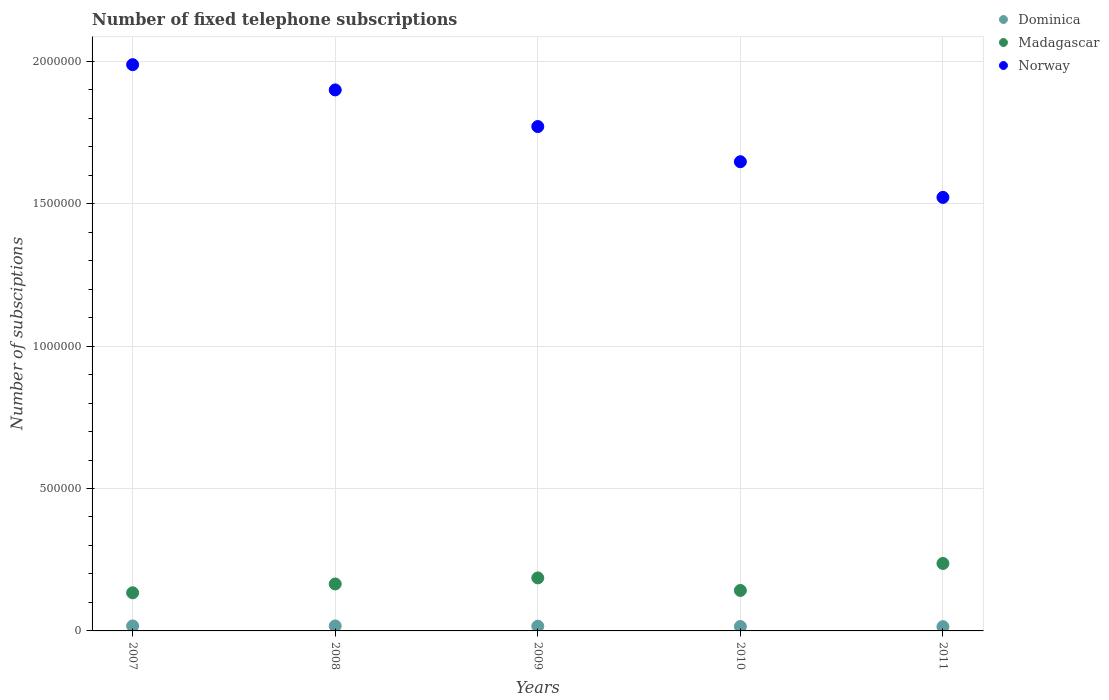Is the number of dotlines equal to the number of legend labels?
Your response must be concise. Yes. What is the number of fixed telephone subscriptions in Norway in 2010?
Ensure brevity in your answer.  1.65e+06. Across all years, what is the maximum number of fixed telephone subscriptions in Madagascar?
Offer a terse response. 2.37e+05. Across all years, what is the minimum number of fixed telephone subscriptions in Dominica?
Keep it short and to the point. 1.50e+04. In which year was the number of fixed telephone subscriptions in Madagascar minimum?
Offer a very short reply. 2007. What is the total number of fixed telephone subscriptions in Norway in the graph?
Make the answer very short. 8.83e+06. What is the difference between the number of fixed telephone subscriptions in Norway in 2008 and that in 2009?
Make the answer very short. 1.29e+05. What is the difference between the number of fixed telephone subscriptions in Norway in 2011 and the number of fixed telephone subscriptions in Dominica in 2009?
Your answer should be compact. 1.51e+06. What is the average number of fixed telephone subscriptions in Norway per year?
Offer a terse response. 1.77e+06. In the year 2011, what is the difference between the number of fixed telephone subscriptions in Norway and number of fixed telephone subscriptions in Dominica?
Your answer should be compact. 1.51e+06. In how many years, is the number of fixed telephone subscriptions in Dominica greater than 1400000?
Ensure brevity in your answer.  0. What is the ratio of the number of fixed telephone subscriptions in Dominica in 2007 to that in 2011?
Your response must be concise. 1.16. What is the difference between the highest and the second highest number of fixed telephone subscriptions in Norway?
Keep it short and to the point. 8.86e+04. What is the difference between the highest and the lowest number of fixed telephone subscriptions in Norway?
Keep it short and to the point. 4.66e+05. Is the sum of the number of fixed telephone subscriptions in Madagascar in 2010 and 2011 greater than the maximum number of fixed telephone subscriptions in Dominica across all years?
Make the answer very short. Yes. Is it the case that in every year, the sum of the number of fixed telephone subscriptions in Norway and number of fixed telephone subscriptions in Dominica  is greater than the number of fixed telephone subscriptions in Madagascar?
Offer a terse response. Yes. Is the number of fixed telephone subscriptions in Madagascar strictly greater than the number of fixed telephone subscriptions in Dominica over the years?
Offer a terse response. Yes. How many years are there in the graph?
Offer a very short reply. 5. Are the values on the major ticks of Y-axis written in scientific E-notation?
Provide a short and direct response. No. Does the graph contain grids?
Provide a succinct answer. Yes. Where does the legend appear in the graph?
Keep it short and to the point. Top right. How are the legend labels stacked?
Your response must be concise. Vertical. What is the title of the graph?
Offer a terse response. Number of fixed telephone subscriptions. What is the label or title of the Y-axis?
Provide a succinct answer. Number of subsciptions. What is the Number of subsciptions of Dominica in 2007?
Keep it short and to the point. 1.74e+04. What is the Number of subsciptions of Madagascar in 2007?
Make the answer very short. 1.34e+05. What is the Number of subsciptions of Norway in 2007?
Your answer should be compact. 1.99e+06. What is the Number of subsciptions in Dominica in 2008?
Ensure brevity in your answer.  1.75e+04. What is the Number of subsciptions of Madagascar in 2008?
Provide a short and direct response. 1.65e+05. What is the Number of subsciptions in Norway in 2008?
Provide a short and direct response. 1.90e+06. What is the Number of subsciptions in Dominica in 2009?
Your answer should be compact. 1.65e+04. What is the Number of subsciptions in Madagascar in 2009?
Your answer should be very brief. 1.86e+05. What is the Number of subsciptions of Norway in 2009?
Ensure brevity in your answer.  1.77e+06. What is the Number of subsciptions in Dominica in 2010?
Your response must be concise. 1.55e+04. What is the Number of subsciptions in Madagascar in 2010?
Offer a terse response. 1.42e+05. What is the Number of subsciptions in Norway in 2010?
Give a very brief answer. 1.65e+06. What is the Number of subsciptions of Dominica in 2011?
Your answer should be compact. 1.50e+04. What is the Number of subsciptions of Madagascar in 2011?
Keep it short and to the point. 2.37e+05. What is the Number of subsciptions in Norway in 2011?
Your response must be concise. 1.52e+06. Across all years, what is the maximum Number of subsciptions of Dominica?
Your answer should be very brief. 1.75e+04. Across all years, what is the maximum Number of subsciptions in Madagascar?
Offer a terse response. 2.37e+05. Across all years, what is the maximum Number of subsciptions in Norway?
Your answer should be very brief. 1.99e+06. Across all years, what is the minimum Number of subsciptions of Dominica?
Offer a terse response. 1.50e+04. Across all years, what is the minimum Number of subsciptions of Madagascar?
Your response must be concise. 1.34e+05. Across all years, what is the minimum Number of subsciptions of Norway?
Your answer should be very brief. 1.52e+06. What is the total Number of subsciptions of Dominica in the graph?
Make the answer very short. 8.19e+04. What is the total Number of subsciptions of Madagascar in the graph?
Provide a short and direct response. 8.64e+05. What is the total Number of subsciptions of Norway in the graph?
Offer a terse response. 8.83e+06. What is the difference between the Number of subsciptions in Dominica in 2007 and that in 2008?
Your answer should be compact. -50. What is the difference between the Number of subsciptions in Madagascar in 2007 and that in 2008?
Your answer should be very brief. -3.10e+04. What is the difference between the Number of subsciptions of Norway in 2007 and that in 2008?
Provide a short and direct response. 8.86e+04. What is the difference between the Number of subsciptions in Dominica in 2007 and that in 2009?
Make the answer very short. 950. What is the difference between the Number of subsciptions in Madagascar in 2007 and that in 2009?
Provide a short and direct response. -5.23e+04. What is the difference between the Number of subsciptions in Norway in 2007 and that in 2009?
Ensure brevity in your answer.  2.17e+05. What is the difference between the Number of subsciptions in Dominica in 2007 and that in 2010?
Offer a terse response. 1966. What is the difference between the Number of subsciptions in Madagascar in 2007 and that in 2010?
Give a very brief answer. -8171. What is the difference between the Number of subsciptions in Norway in 2007 and that in 2010?
Ensure brevity in your answer.  3.41e+05. What is the difference between the Number of subsciptions of Dominica in 2007 and that in 2011?
Your answer should be compact. 2458. What is the difference between the Number of subsciptions in Madagascar in 2007 and that in 2011?
Give a very brief answer. -1.03e+05. What is the difference between the Number of subsciptions of Norway in 2007 and that in 2011?
Your answer should be very brief. 4.66e+05. What is the difference between the Number of subsciptions in Madagascar in 2008 and that in 2009?
Keep it short and to the point. -2.13e+04. What is the difference between the Number of subsciptions in Norway in 2008 and that in 2009?
Offer a very short reply. 1.29e+05. What is the difference between the Number of subsciptions of Dominica in 2008 and that in 2010?
Your answer should be compact. 2016. What is the difference between the Number of subsciptions of Madagascar in 2008 and that in 2010?
Ensure brevity in your answer.  2.28e+04. What is the difference between the Number of subsciptions in Norway in 2008 and that in 2010?
Your response must be concise. 2.52e+05. What is the difference between the Number of subsciptions in Dominica in 2008 and that in 2011?
Provide a succinct answer. 2508. What is the difference between the Number of subsciptions in Madagascar in 2008 and that in 2011?
Keep it short and to the point. -7.20e+04. What is the difference between the Number of subsciptions of Norway in 2008 and that in 2011?
Provide a short and direct response. 3.77e+05. What is the difference between the Number of subsciptions in Dominica in 2009 and that in 2010?
Provide a short and direct response. 1016. What is the difference between the Number of subsciptions of Madagascar in 2009 and that in 2010?
Your answer should be very brief. 4.41e+04. What is the difference between the Number of subsciptions in Norway in 2009 and that in 2010?
Make the answer very short. 1.24e+05. What is the difference between the Number of subsciptions in Dominica in 2009 and that in 2011?
Give a very brief answer. 1508. What is the difference between the Number of subsciptions of Madagascar in 2009 and that in 2011?
Make the answer very short. -5.07e+04. What is the difference between the Number of subsciptions in Norway in 2009 and that in 2011?
Give a very brief answer. 2.49e+05. What is the difference between the Number of subsciptions of Dominica in 2010 and that in 2011?
Ensure brevity in your answer.  492. What is the difference between the Number of subsciptions in Madagascar in 2010 and that in 2011?
Your answer should be compact. -9.48e+04. What is the difference between the Number of subsciptions in Norway in 2010 and that in 2011?
Provide a short and direct response. 1.25e+05. What is the difference between the Number of subsciptions in Dominica in 2007 and the Number of subsciptions in Madagascar in 2008?
Make the answer very short. -1.47e+05. What is the difference between the Number of subsciptions in Dominica in 2007 and the Number of subsciptions in Norway in 2008?
Provide a short and direct response. -1.88e+06. What is the difference between the Number of subsciptions in Madagascar in 2007 and the Number of subsciptions in Norway in 2008?
Offer a terse response. -1.77e+06. What is the difference between the Number of subsciptions in Dominica in 2007 and the Number of subsciptions in Madagascar in 2009?
Your response must be concise. -1.69e+05. What is the difference between the Number of subsciptions in Dominica in 2007 and the Number of subsciptions in Norway in 2009?
Make the answer very short. -1.75e+06. What is the difference between the Number of subsciptions in Madagascar in 2007 and the Number of subsciptions in Norway in 2009?
Provide a succinct answer. -1.64e+06. What is the difference between the Number of subsciptions in Dominica in 2007 and the Number of subsciptions in Madagascar in 2010?
Keep it short and to the point. -1.25e+05. What is the difference between the Number of subsciptions of Dominica in 2007 and the Number of subsciptions of Norway in 2010?
Your response must be concise. -1.63e+06. What is the difference between the Number of subsciptions in Madagascar in 2007 and the Number of subsciptions in Norway in 2010?
Give a very brief answer. -1.51e+06. What is the difference between the Number of subsciptions of Dominica in 2007 and the Number of subsciptions of Madagascar in 2011?
Your answer should be very brief. -2.19e+05. What is the difference between the Number of subsciptions in Dominica in 2007 and the Number of subsciptions in Norway in 2011?
Offer a very short reply. -1.50e+06. What is the difference between the Number of subsciptions of Madagascar in 2007 and the Number of subsciptions of Norway in 2011?
Provide a short and direct response. -1.39e+06. What is the difference between the Number of subsciptions of Dominica in 2008 and the Number of subsciptions of Madagascar in 2009?
Offer a terse response. -1.69e+05. What is the difference between the Number of subsciptions of Dominica in 2008 and the Number of subsciptions of Norway in 2009?
Keep it short and to the point. -1.75e+06. What is the difference between the Number of subsciptions of Madagascar in 2008 and the Number of subsciptions of Norway in 2009?
Your answer should be very brief. -1.61e+06. What is the difference between the Number of subsciptions in Dominica in 2008 and the Number of subsciptions in Madagascar in 2010?
Provide a succinct answer. -1.25e+05. What is the difference between the Number of subsciptions of Dominica in 2008 and the Number of subsciptions of Norway in 2010?
Your answer should be compact. -1.63e+06. What is the difference between the Number of subsciptions in Madagascar in 2008 and the Number of subsciptions in Norway in 2010?
Provide a short and direct response. -1.48e+06. What is the difference between the Number of subsciptions of Dominica in 2008 and the Number of subsciptions of Madagascar in 2011?
Provide a succinct answer. -2.19e+05. What is the difference between the Number of subsciptions of Dominica in 2008 and the Number of subsciptions of Norway in 2011?
Make the answer very short. -1.50e+06. What is the difference between the Number of subsciptions of Madagascar in 2008 and the Number of subsciptions of Norway in 2011?
Provide a succinct answer. -1.36e+06. What is the difference between the Number of subsciptions of Dominica in 2009 and the Number of subsciptions of Madagascar in 2010?
Make the answer very short. -1.26e+05. What is the difference between the Number of subsciptions in Dominica in 2009 and the Number of subsciptions in Norway in 2010?
Your answer should be compact. -1.63e+06. What is the difference between the Number of subsciptions of Madagascar in 2009 and the Number of subsciptions of Norway in 2010?
Your answer should be compact. -1.46e+06. What is the difference between the Number of subsciptions of Dominica in 2009 and the Number of subsciptions of Madagascar in 2011?
Your response must be concise. -2.20e+05. What is the difference between the Number of subsciptions in Dominica in 2009 and the Number of subsciptions in Norway in 2011?
Offer a very short reply. -1.51e+06. What is the difference between the Number of subsciptions of Madagascar in 2009 and the Number of subsciptions of Norway in 2011?
Offer a terse response. -1.34e+06. What is the difference between the Number of subsciptions in Dominica in 2010 and the Number of subsciptions in Madagascar in 2011?
Keep it short and to the point. -2.21e+05. What is the difference between the Number of subsciptions of Dominica in 2010 and the Number of subsciptions of Norway in 2011?
Your response must be concise. -1.51e+06. What is the difference between the Number of subsciptions in Madagascar in 2010 and the Number of subsciptions in Norway in 2011?
Ensure brevity in your answer.  -1.38e+06. What is the average Number of subsciptions in Dominica per year?
Provide a short and direct response. 1.64e+04. What is the average Number of subsciptions in Madagascar per year?
Make the answer very short. 1.73e+05. What is the average Number of subsciptions in Norway per year?
Keep it short and to the point. 1.77e+06. In the year 2007, what is the difference between the Number of subsciptions in Dominica and Number of subsciptions in Madagascar?
Provide a short and direct response. -1.16e+05. In the year 2007, what is the difference between the Number of subsciptions of Dominica and Number of subsciptions of Norway?
Offer a terse response. -1.97e+06. In the year 2007, what is the difference between the Number of subsciptions in Madagascar and Number of subsciptions in Norway?
Keep it short and to the point. -1.85e+06. In the year 2008, what is the difference between the Number of subsciptions in Dominica and Number of subsciptions in Madagascar?
Your answer should be very brief. -1.47e+05. In the year 2008, what is the difference between the Number of subsciptions of Dominica and Number of subsciptions of Norway?
Your response must be concise. -1.88e+06. In the year 2008, what is the difference between the Number of subsciptions of Madagascar and Number of subsciptions of Norway?
Offer a very short reply. -1.73e+06. In the year 2009, what is the difference between the Number of subsciptions of Dominica and Number of subsciptions of Madagascar?
Offer a very short reply. -1.70e+05. In the year 2009, what is the difference between the Number of subsciptions in Dominica and Number of subsciptions in Norway?
Give a very brief answer. -1.75e+06. In the year 2009, what is the difference between the Number of subsciptions in Madagascar and Number of subsciptions in Norway?
Your answer should be compact. -1.58e+06. In the year 2010, what is the difference between the Number of subsciptions of Dominica and Number of subsciptions of Madagascar?
Your response must be concise. -1.27e+05. In the year 2010, what is the difference between the Number of subsciptions of Dominica and Number of subsciptions of Norway?
Your answer should be very brief. -1.63e+06. In the year 2010, what is the difference between the Number of subsciptions in Madagascar and Number of subsciptions in Norway?
Your answer should be very brief. -1.51e+06. In the year 2011, what is the difference between the Number of subsciptions in Dominica and Number of subsciptions in Madagascar?
Make the answer very short. -2.22e+05. In the year 2011, what is the difference between the Number of subsciptions of Dominica and Number of subsciptions of Norway?
Your response must be concise. -1.51e+06. In the year 2011, what is the difference between the Number of subsciptions in Madagascar and Number of subsciptions in Norway?
Provide a succinct answer. -1.29e+06. What is the ratio of the Number of subsciptions in Dominica in 2007 to that in 2008?
Offer a terse response. 1. What is the ratio of the Number of subsciptions of Madagascar in 2007 to that in 2008?
Offer a terse response. 0.81. What is the ratio of the Number of subsciptions in Norway in 2007 to that in 2008?
Make the answer very short. 1.05. What is the ratio of the Number of subsciptions of Dominica in 2007 to that in 2009?
Your answer should be compact. 1.06. What is the ratio of the Number of subsciptions of Madagascar in 2007 to that in 2009?
Ensure brevity in your answer.  0.72. What is the ratio of the Number of subsciptions in Norway in 2007 to that in 2009?
Your response must be concise. 1.12. What is the ratio of the Number of subsciptions in Dominica in 2007 to that in 2010?
Ensure brevity in your answer.  1.13. What is the ratio of the Number of subsciptions of Madagascar in 2007 to that in 2010?
Offer a terse response. 0.94. What is the ratio of the Number of subsciptions in Norway in 2007 to that in 2010?
Provide a succinct answer. 1.21. What is the ratio of the Number of subsciptions in Dominica in 2007 to that in 2011?
Your answer should be very brief. 1.16. What is the ratio of the Number of subsciptions of Madagascar in 2007 to that in 2011?
Make the answer very short. 0.57. What is the ratio of the Number of subsciptions of Norway in 2007 to that in 2011?
Provide a succinct answer. 1.31. What is the ratio of the Number of subsciptions of Dominica in 2008 to that in 2009?
Your answer should be very brief. 1.06. What is the ratio of the Number of subsciptions in Madagascar in 2008 to that in 2009?
Ensure brevity in your answer.  0.89. What is the ratio of the Number of subsciptions in Norway in 2008 to that in 2009?
Keep it short and to the point. 1.07. What is the ratio of the Number of subsciptions in Dominica in 2008 to that in 2010?
Provide a succinct answer. 1.13. What is the ratio of the Number of subsciptions of Madagascar in 2008 to that in 2010?
Offer a terse response. 1.16. What is the ratio of the Number of subsciptions in Norway in 2008 to that in 2010?
Provide a succinct answer. 1.15. What is the ratio of the Number of subsciptions of Dominica in 2008 to that in 2011?
Your answer should be compact. 1.17. What is the ratio of the Number of subsciptions of Madagascar in 2008 to that in 2011?
Offer a terse response. 0.7. What is the ratio of the Number of subsciptions in Norway in 2008 to that in 2011?
Your answer should be compact. 1.25. What is the ratio of the Number of subsciptions of Dominica in 2009 to that in 2010?
Ensure brevity in your answer.  1.07. What is the ratio of the Number of subsciptions of Madagascar in 2009 to that in 2010?
Your response must be concise. 1.31. What is the ratio of the Number of subsciptions of Norway in 2009 to that in 2010?
Make the answer very short. 1.07. What is the ratio of the Number of subsciptions in Dominica in 2009 to that in 2011?
Give a very brief answer. 1.1. What is the ratio of the Number of subsciptions in Madagascar in 2009 to that in 2011?
Keep it short and to the point. 0.79. What is the ratio of the Number of subsciptions in Norway in 2009 to that in 2011?
Your answer should be very brief. 1.16. What is the ratio of the Number of subsciptions in Dominica in 2010 to that in 2011?
Offer a terse response. 1.03. What is the ratio of the Number of subsciptions in Madagascar in 2010 to that in 2011?
Offer a very short reply. 0.6. What is the ratio of the Number of subsciptions in Norway in 2010 to that in 2011?
Offer a terse response. 1.08. What is the difference between the highest and the second highest Number of subsciptions of Dominica?
Your answer should be compact. 50. What is the difference between the highest and the second highest Number of subsciptions in Madagascar?
Keep it short and to the point. 5.07e+04. What is the difference between the highest and the second highest Number of subsciptions of Norway?
Your response must be concise. 8.86e+04. What is the difference between the highest and the lowest Number of subsciptions in Dominica?
Keep it short and to the point. 2508. What is the difference between the highest and the lowest Number of subsciptions in Madagascar?
Give a very brief answer. 1.03e+05. What is the difference between the highest and the lowest Number of subsciptions of Norway?
Provide a short and direct response. 4.66e+05. 